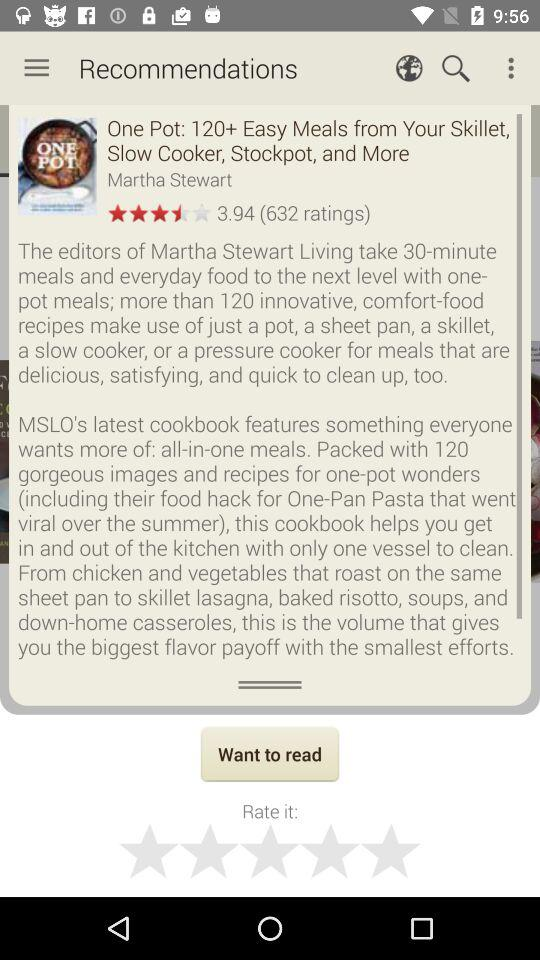What is the number of ratings for "One Pot"? The number of ratings for "One Pot" is 632. 